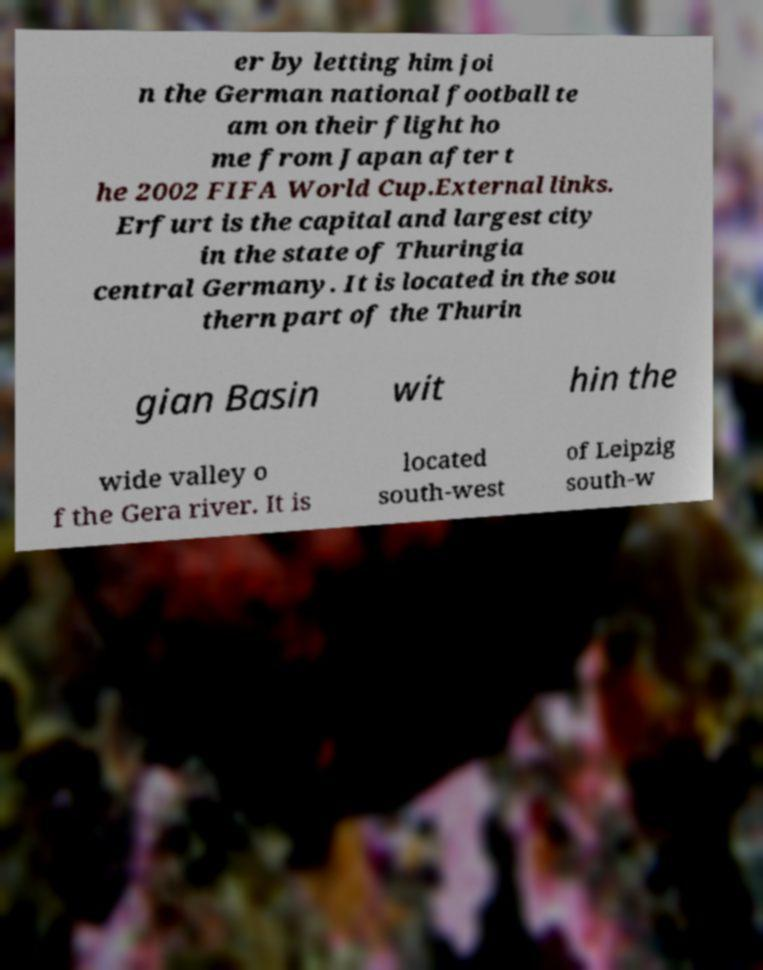For documentation purposes, I need the text within this image transcribed. Could you provide that? er by letting him joi n the German national football te am on their flight ho me from Japan after t he 2002 FIFA World Cup.External links. Erfurt is the capital and largest city in the state of Thuringia central Germany. It is located in the sou thern part of the Thurin gian Basin wit hin the wide valley o f the Gera river. It is located south-west of Leipzig south-w 